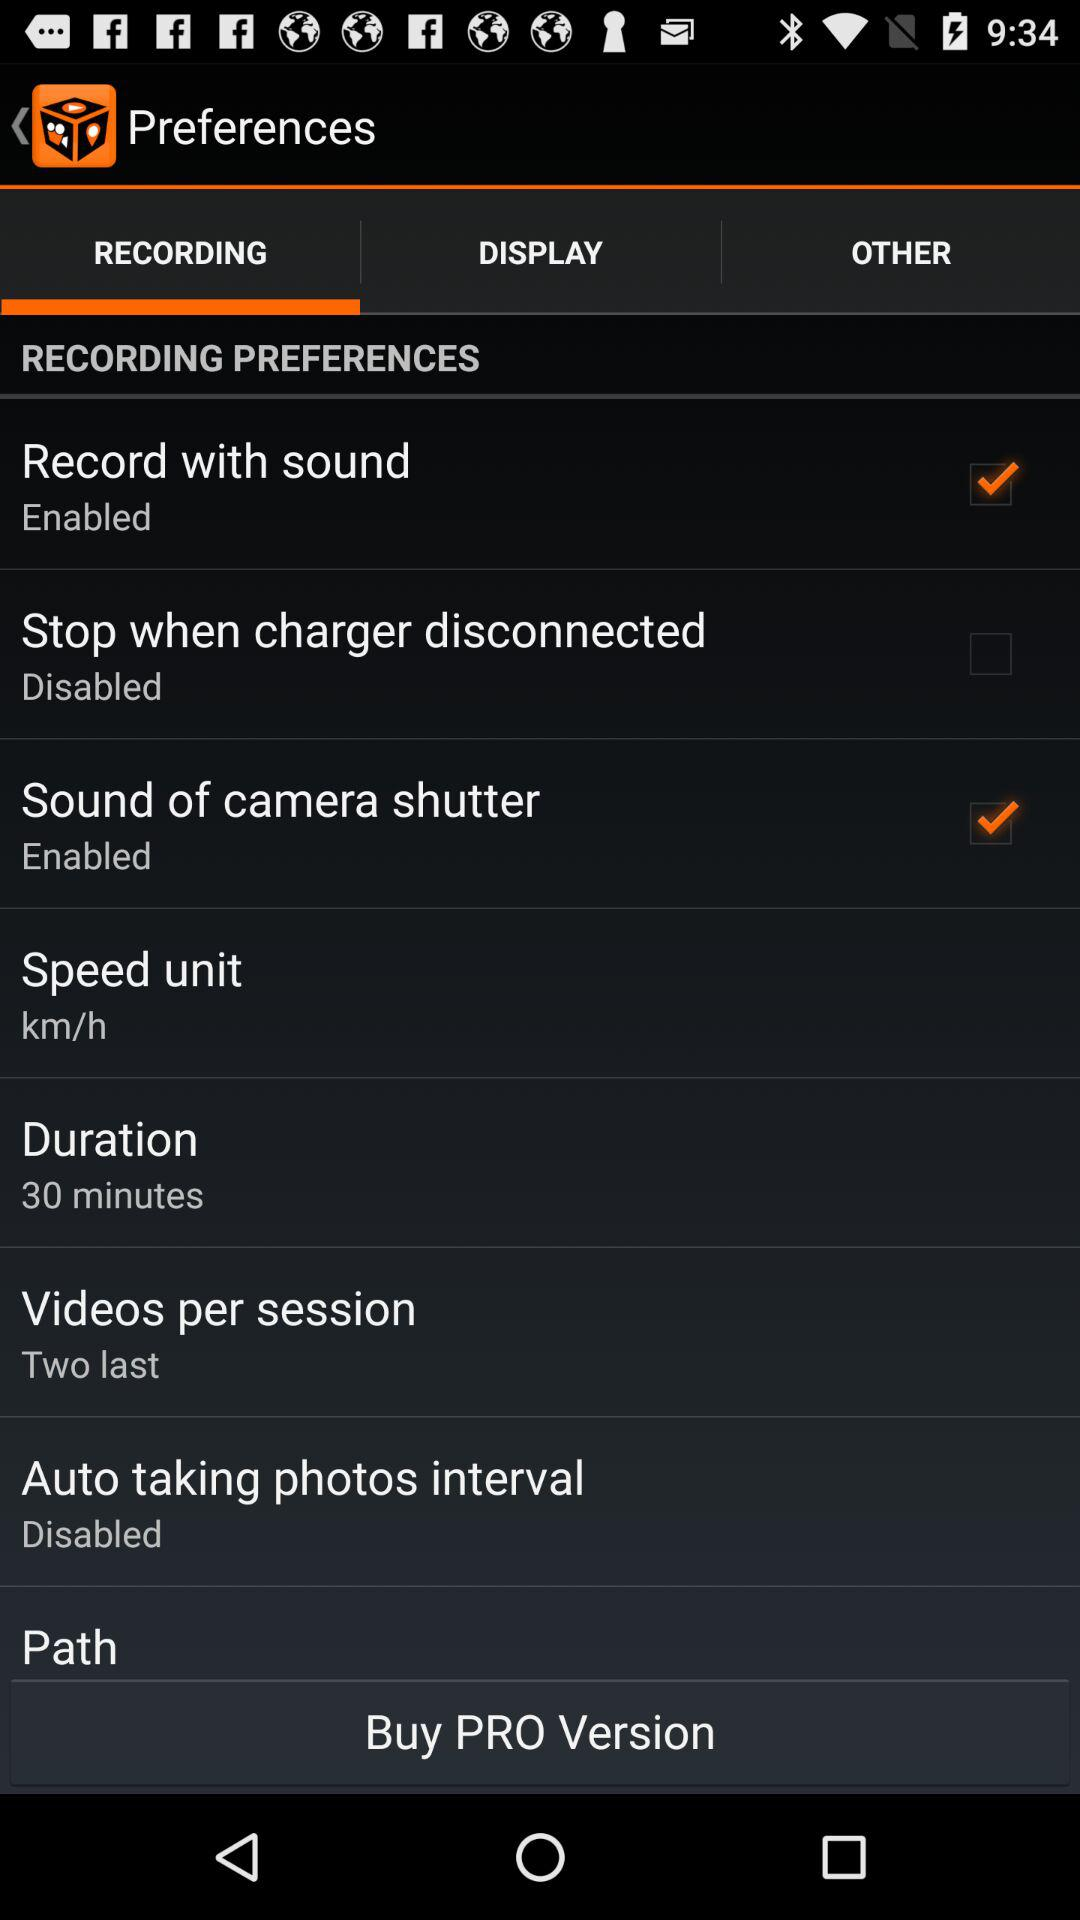What is the duration? The duration is 30 minutes. 